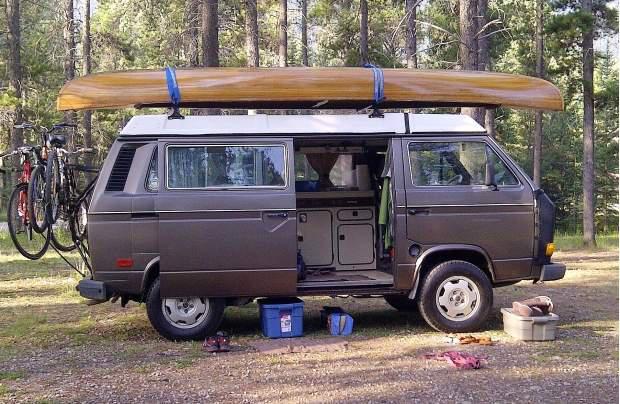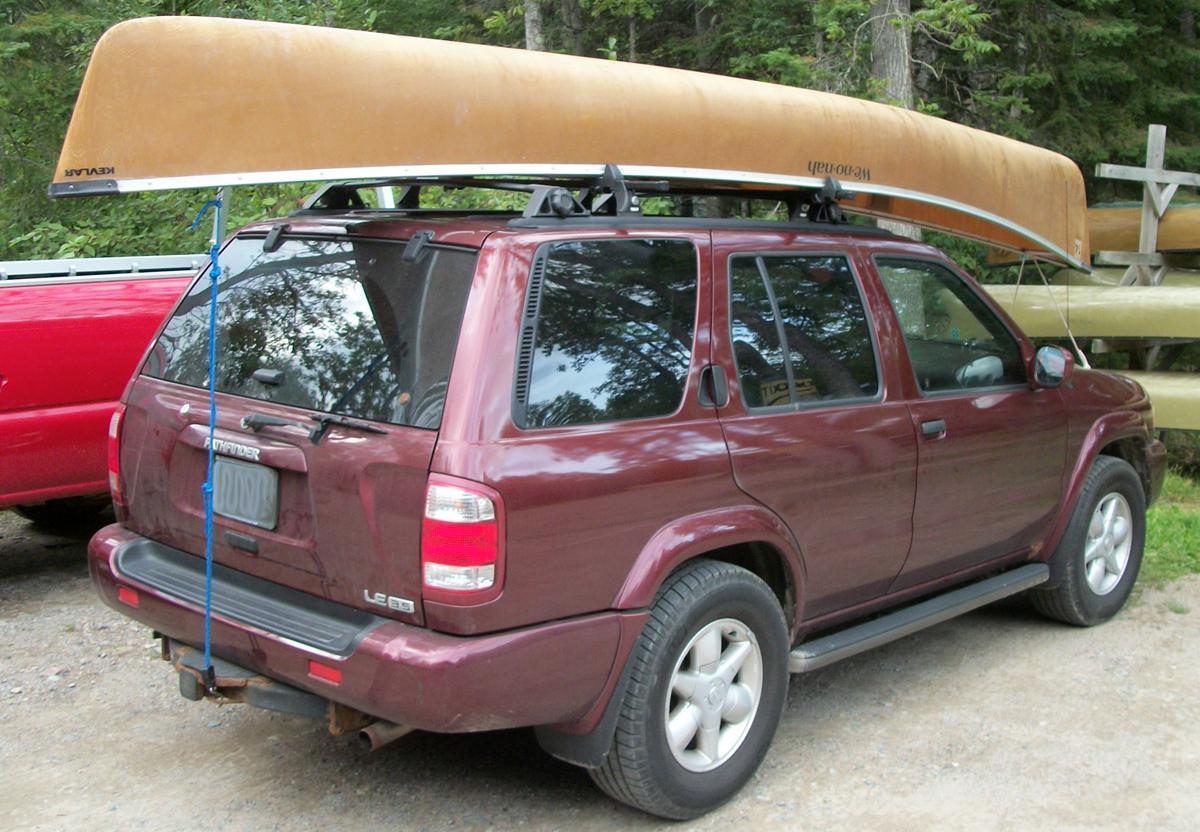The first image is the image on the left, the second image is the image on the right. For the images shown, is this caption "All vehicles have a single boat secured to the roof." true? Answer yes or no. Yes. 